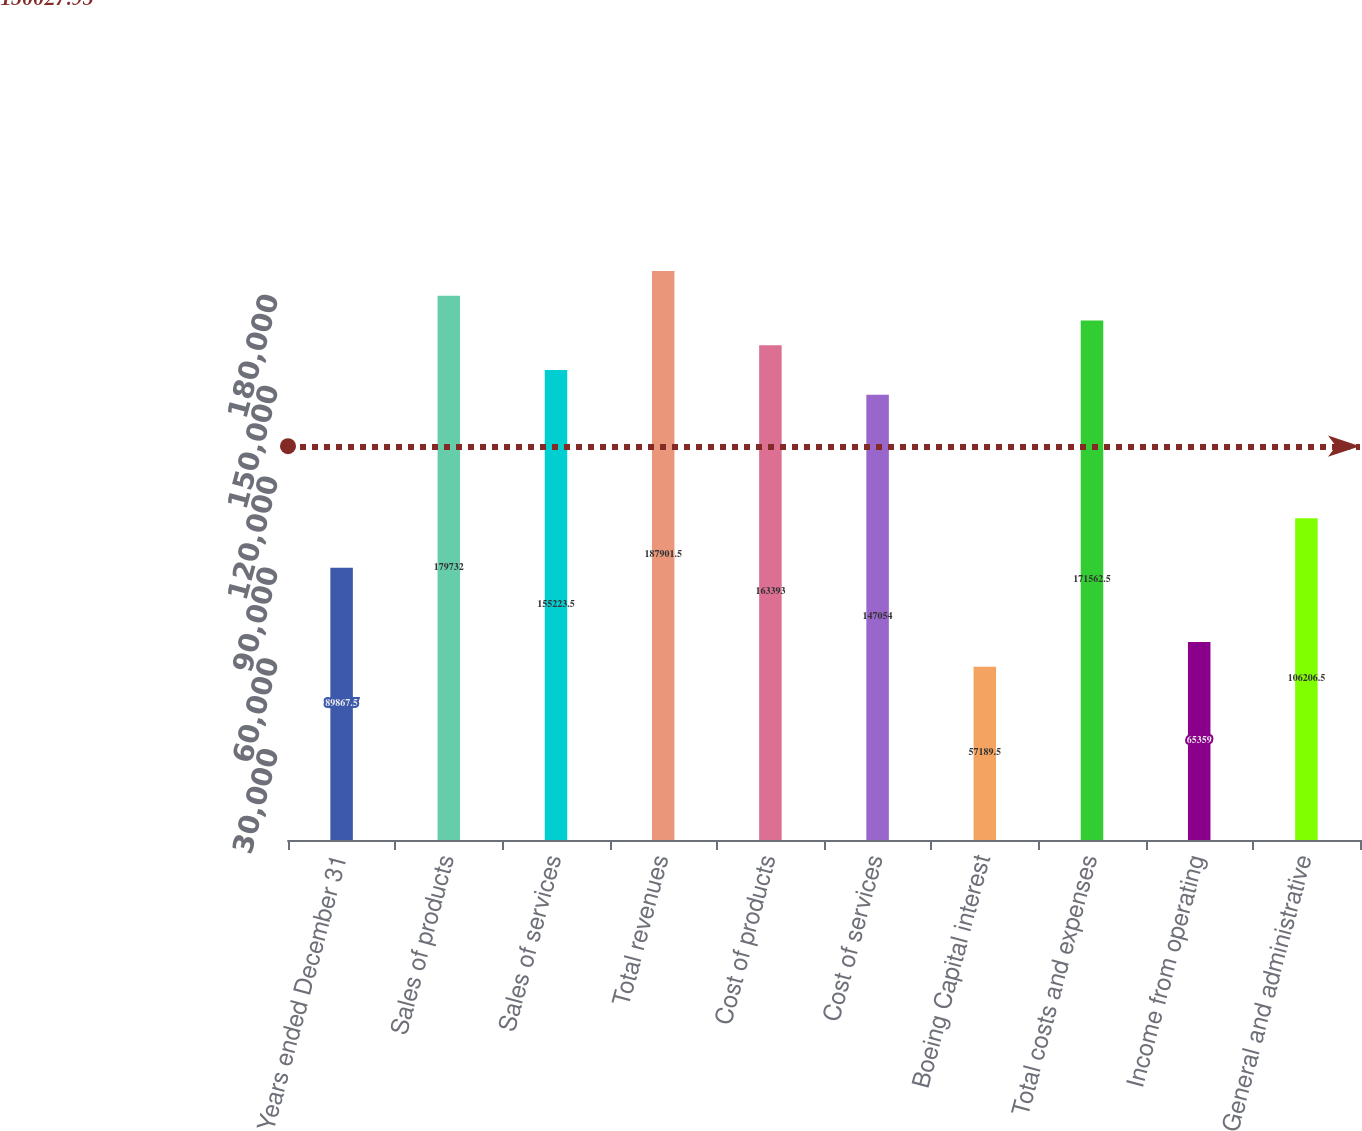Convert chart to OTSL. <chart><loc_0><loc_0><loc_500><loc_500><bar_chart><fcel>Years ended December 31<fcel>Sales of products<fcel>Sales of services<fcel>Total revenues<fcel>Cost of products<fcel>Cost of services<fcel>Boeing Capital interest<fcel>Total costs and expenses<fcel>Income from operating<fcel>General and administrative<nl><fcel>89867.5<fcel>179732<fcel>155224<fcel>187902<fcel>163393<fcel>147054<fcel>57189.5<fcel>171562<fcel>65359<fcel>106206<nl></chart> 